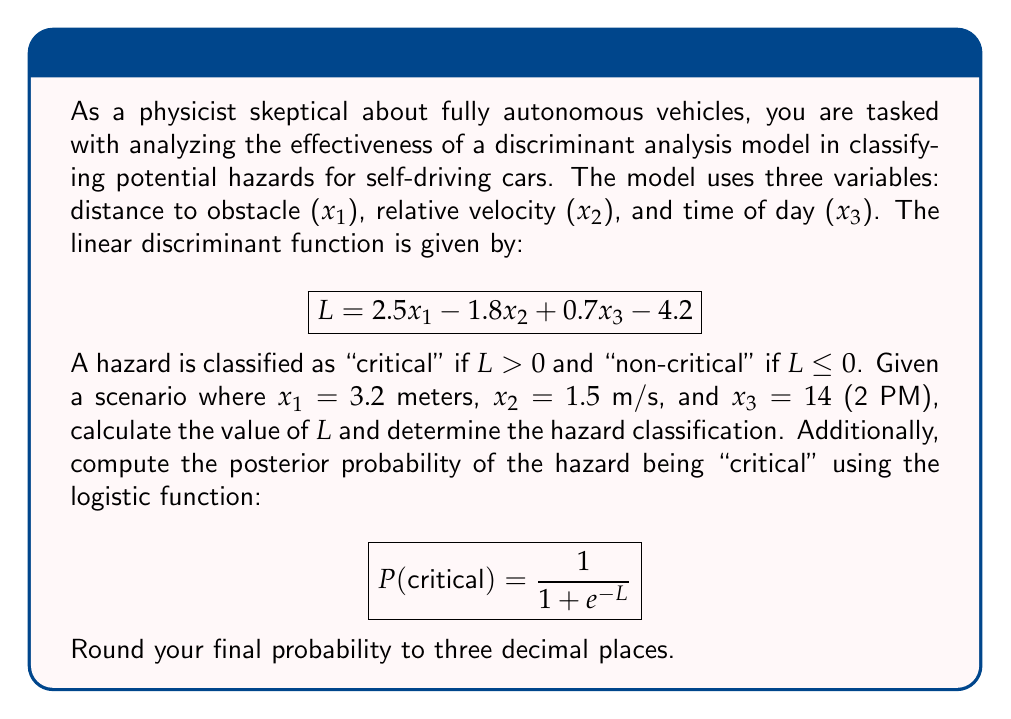Can you solve this math problem? To solve this problem, we'll follow these steps:

1. Calculate the value of $L$ using the given discriminant function and variable values.
2. Determine the hazard classification based on the value of $L$.
3. Compute the posterior probability using the logistic function.

Step 1: Calculating $L$

We substitute the given values into the linear discriminant function:

$$\begin{align}
L &= 2.5x_1 - 1.8x_2 + 0.7x_3 - 4.2 \\
&= 2.5(3.2) - 1.8(1.5) + 0.7(14) - 4.2 \\
&= 8 - 2.7 + 9.8 - 4.2 \\
&= 10.9
\end{align}$$

Step 2: Determining hazard classification

Since $L = 10.9 > 0$, the hazard is classified as "critical".

Step 3: Computing the posterior probability

We use the logistic function to calculate the probability:

$$\begin{align}
P(\text{critical}) &= \frac{1}{1 + e^{-L}} \\
&= \frac{1}{1 + e^{-10.9}} \\
&= \frac{1}{1 + 0.00001849} \\
&≈ 0.999981509
\end{align}$$

Rounding to three decimal places, we get 1.000.
Answer: $L = 10.9$, hazard classification: critical, $P(\text{critical}) = 1.000$ 